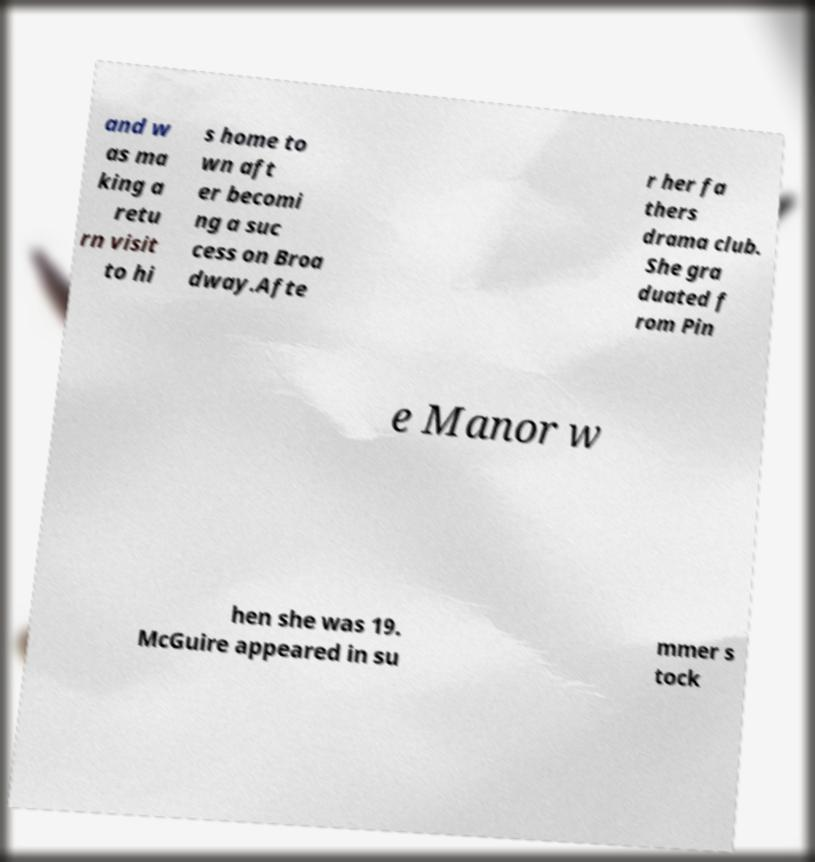What messages or text are displayed in this image? I need them in a readable, typed format. and w as ma king a retu rn visit to hi s home to wn aft er becomi ng a suc cess on Broa dway.Afte r her fa thers drama club. She gra duated f rom Pin e Manor w hen she was 19. McGuire appeared in su mmer s tock 